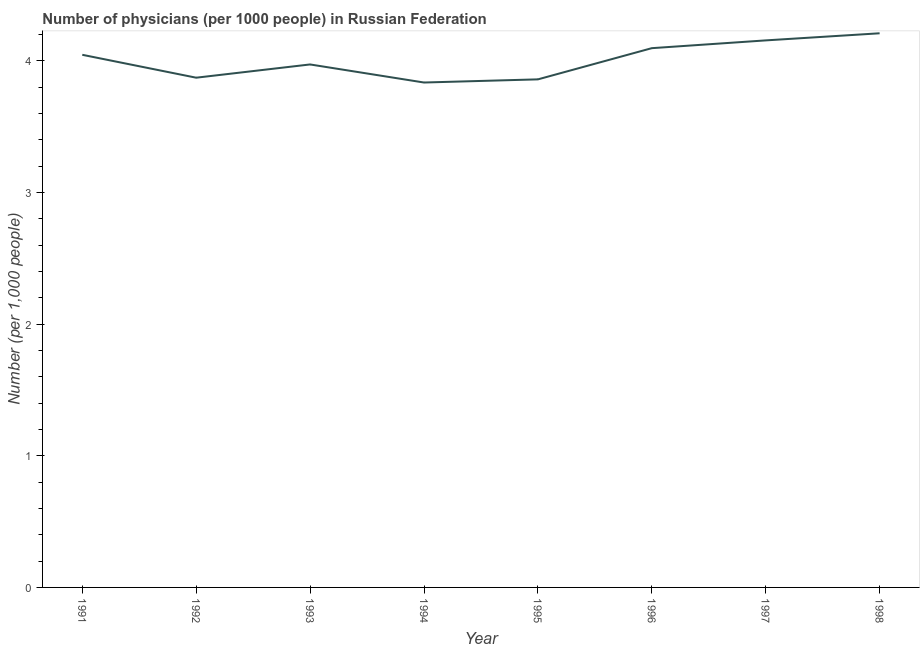What is the number of physicians in 1991?
Keep it short and to the point. 4.05. Across all years, what is the maximum number of physicians?
Offer a terse response. 4.21. Across all years, what is the minimum number of physicians?
Provide a succinct answer. 3.84. In which year was the number of physicians maximum?
Your answer should be very brief. 1998. In which year was the number of physicians minimum?
Provide a succinct answer. 1994. What is the sum of the number of physicians?
Your response must be concise. 32.04. What is the difference between the number of physicians in 1992 and 1993?
Provide a short and direct response. -0.1. What is the average number of physicians per year?
Ensure brevity in your answer.  4.01. What is the median number of physicians?
Provide a short and direct response. 4.01. In how many years, is the number of physicians greater than 1.4 ?
Offer a terse response. 8. Do a majority of the years between 1995 and 1996 (inclusive) have number of physicians greater than 3.2 ?
Your answer should be very brief. Yes. What is the ratio of the number of physicians in 1992 to that in 1996?
Your answer should be very brief. 0.95. Is the difference between the number of physicians in 1993 and 1994 greater than the difference between any two years?
Offer a terse response. No. What is the difference between the highest and the second highest number of physicians?
Offer a terse response. 0.05. What is the difference between the highest and the lowest number of physicians?
Give a very brief answer. 0.37. Does the number of physicians monotonically increase over the years?
Offer a terse response. No. How many years are there in the graph?
Your response must be concise. 8. What is the difference between two consecutive major ticks on the Y-axis?
Give a very brief answer. 1. Does the graph contain any zero values?
Keep it short and to the point. No. What is the title of the graph?
Your answer should be compact. Number of physicians (per 1000 people) in Russian Federation. What is the label or title of the Y-axis?
Your answer should be compact. Number (per 1,0 people). What is the Number (per 1,000 people) in 1991?
Your response must be concise. 4.05. What is the Number (per 1,000 people) in 1992?
Your answer should be compact. 3.87. What is the Number (per 1,000 people) in 1993?
Provide a short and direct response. 3.97. What is the Number (per 1,000 people) in 1994?
Keep it short and to the point. 3.84. What is the Number (per 1,000 people) of 1995?
Give a very brief answer. 3.86. What is the Number (per 1,000 people) in 1996?
Provide a short and direct response. 4.1. What is the Number (per 1,000 people) of 1997?
Your answer should be very brief. 4.16. What is the Number (per 1,000 people) in 1998?
Provide a succinct answer. 4.21. What is the difference between the Number (per 1,000 people) in 1991 and 1992?
Your answer should be compact. 0.17. What is the difference between the Number (per 1,000 people) in 1991 and 1993?
Keep it short and to the point. 0.07. What is the difference between the Number (per 1,000 people) in 1991 and 1994?
Keep it short and to the point. 0.21. What is the difference between the Number (per 1,000 people) in 1991 and 1995?
Offer a terse response. 0.19. What is the difference between the Number (per 1,000 people) in 1991 and 1996?
Make the answer very short. -0.05. What is the difference between the Number (per 1,000 people) in 1991 and 1997?
Ensure brevity in your answer.  -0.11. What is the difference between the Number (per 1,000 people) in 1991 and 1998?
Offer a very short reply. -0.16. What is the difference between the Number (per 1,000 people) in 1992 and 1993?
Your response must be concise. -0.1. What is the difference between the Number (per 1,000 people) in 1992 and 1994?
Offer a terse response. 0.04. What is the difference between the Number (per 1,000 people) in 1992 and 1995?
Give a very brief answer. 0.01. What is the difference between the Number (per 1,000 people) in 1992 and 1996?
Provide a succinct answer. -0.22. What is the difference between the Number (per 1,000 people) in 1992 and 1997?
Keep it short and to the point. -0.28. What is the difference between the Number (per 1,000 people) in 1992 and 1998?
Ensure brevity in your answer.  -0.34. What is the difference between the Number (per 1,000 people) in 1993 and 1994?
Your answer should be very brief. 0.14. What is the difference between the Number (per 1,000 people) in 1993 and 1995?
Ensure brevity in your answer.  0.11. What is the difference between the Number (per 1,000 people) in 1993 and 1996?
Provide a short and direct response. -0.12. What is the difference between the Number (per 1,000 people) in 1993 and 1997?
Your response must be concise. -0.18. What is the difference between the Number (per 1,000 people) in 1993 and 1998?
Make the answer very short. -0.24. What is the difference between the Number (per 1,000 people) in 1994 and 1995?
Your response must be concise. -0.02. What is the difference between the Number (per 1,000 people) in 1994 and 1996?
Your answer should be very brief. -0.26. What is the difference between the Number (per 1,000 people) in 1994 and 1997?
Your answer should be compact. -0.32. What is the difference between the Number (per 1,000 people) in 1994 and 1998?
Your response must be concise. -0.37. What is the difference between the Number (per 1,000 people) in 1995 and 1996?
Your answer should be compact. -0.24. What is the difference between the Number (per 1,000 people) in 1995 and 1997?
Ensure brevity in your answer.  -0.3. What is the difference between the Number (per 1,000 people) in 1995 and 1998?
Your response must be concise. -0.35. What is the difference between the Number (per 1,000 people) in 1996 and 1997?
Provide a short and direct response. -0.06. What is the difference between the Number (per 1,000 people) in 1996 and 1998?
Provide a short and direct response. -0.11. What is the difference between the Number (per 1,000 people) in 1997 and 1998?
Make the answer very short. -0.05. What is the ratio of the Number (per 1,000 people) in 1991 to that in 1992?
Your response must be concise. 1.04. What is the ratio of the Number (per 1,000 people) in 1991 to that in 1993?
Provide a succinct answer. 1.02. What is the ratio of the Number (per 1,000 people) in 1991 to that in 1994?
Offer a very short reply. 1.05. What is the ratio of the Number (per 1,000 people) in 1991 to that in 1995?
Offer a very short reply. 1.05. What is the ratio of the Number (per 1,000 people) in 1991 to that in 1998?
Keep it short and to the point. 0.96. What is the ratio of the Number (per 1,000 people) in 1992 to that in 1993?
Offer a terse response. 0.97. What is the ratio of the Number (per 1,000 people) in 1992 to that in 1994?
Your answer should be very brief. 1.01. What is the ratio of the Number (per 1,000 people) in 1992 to that in 1996?
Keep it short and to the point. 0.94. What is the ratio of the Number (per 1,000 people) in 1992 to that in 1997?
Offer a terse response. 0.93. What is the ratio of the Number (per 1,000 people) in 1992 to that in 1998?
Provide a short and direct response. 0.92. What is the ratio of the Number (per 1,000 people) in 1993 to that in 1994?
Provide a succinct answer. 1.04. What is the ratio of the Number (per 1,000 people) in 1993 to that in 1995?
Offer a very short reply. 1.03. What is the ratio of the Number (per 1,000 people) in 1993 to that in 1997?
Your answer should be very brief. 0.96. What is the ratio of the Number (per 1,000 people) in 1993 to that in 1998?
Your response must be concise. 0.94. What is the ratio of the Number (per 1,000 people) in 1994 to that in 1995?
Your answer should be compact. 0.99. What is the ratio of the Number (per 1,000 people) in 1994 to that in 1996?
Your response must be concise. 0.94. What is the ratio of the Number (per 1,000 people) in 1994 to that in 1997?
Provide a short and direct response. 0.92. What is the ratio of the Number (per 1,000 people) in 1994 to that in 1998?
Offer a terse response. 0.91. What is the ratio of the Number (per 1,000 people) in 1995 to that in 1996?
Your answer should be very brief. 0.94. What is the ratio of the Number (per 1,000 people) in 1995 to that in 1997?
Your answer should be very brief. 0.93. What is the ratio of the Number (per 1,000 people) in 1995 to that in 1998?
Keep it short and to the point. 0.92. What is the ratio of the Number (per 1,000 people) in 1996 to that in 1997?
Your answer should be compact. 0.99. What is the ratio of the Number (per 1,000 people) in 1996 to that in 1998?
Keep it short and to the point. 0.97. 